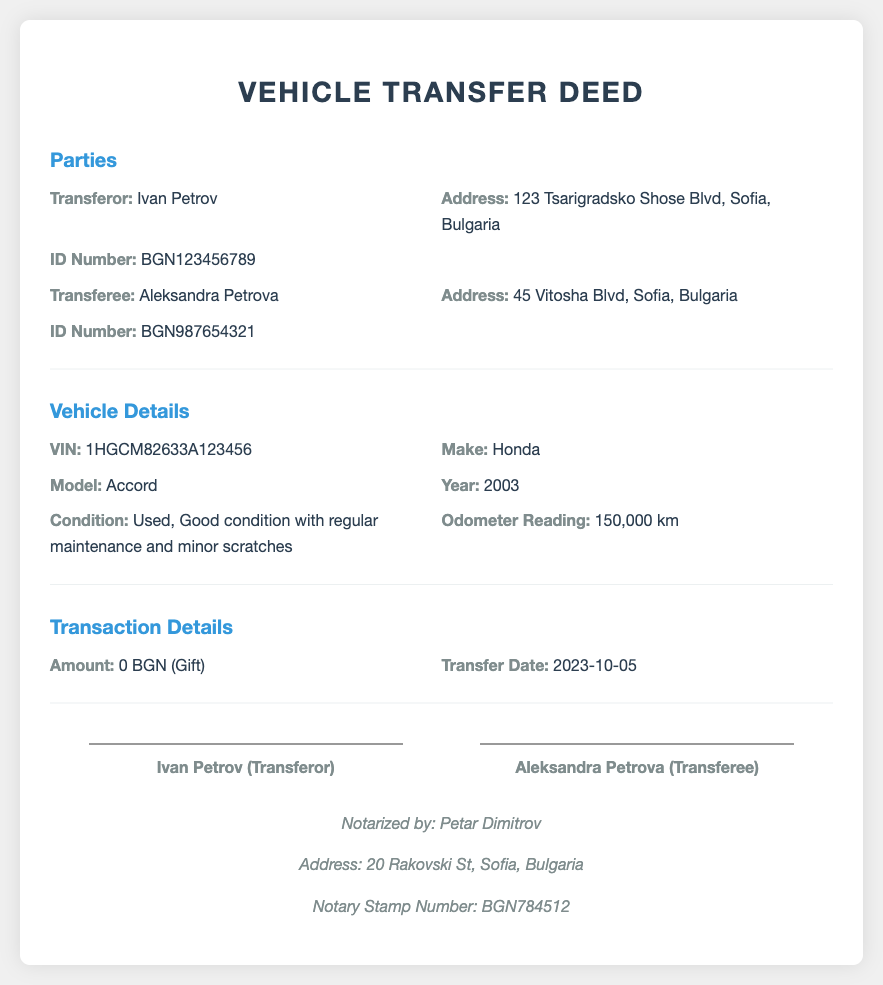What is the VIN of the vehicle? The VIN is a unique identifier for the vehicle mentioned in the document.
Answer: 1HGCM82633A123456 Who is the transferor? The transferor is the person transferring ownership of the vehicle.
Answer: Ivan Petrov What is the condition of the vehicle? The condition of the vehicle provides insight into its state before transfer.
Answer: Used, Good condition with regular maintenance and minor scratches What is the transaction amount? The transaction amount indicates the financial aspect of the vehicle transfer.
Answer: 0 BGN (Gift) When was the transfer date? The transfer date specifies when the ownership of the vehicle changed.
Answer: 2023-10-05 What is the address of the transferee? The address provides location details for the person receiving the vehicle.
Answer: 45 Vitosha Blvd, Sofia, Bulgaria How many kilometers is the odometer reading? The odometer reading shows the distance the vehicle has traveled, relevant for assessing wear.
Answer: 150,000 km Who notarized the document? The notary is responsible for verifying and attesting the authenticity of the document.
Answer: Petar Dimitrov What type of document is this? The type of document indicates its legal purpose and context.
Answer: Vehicle Transfer Deed 